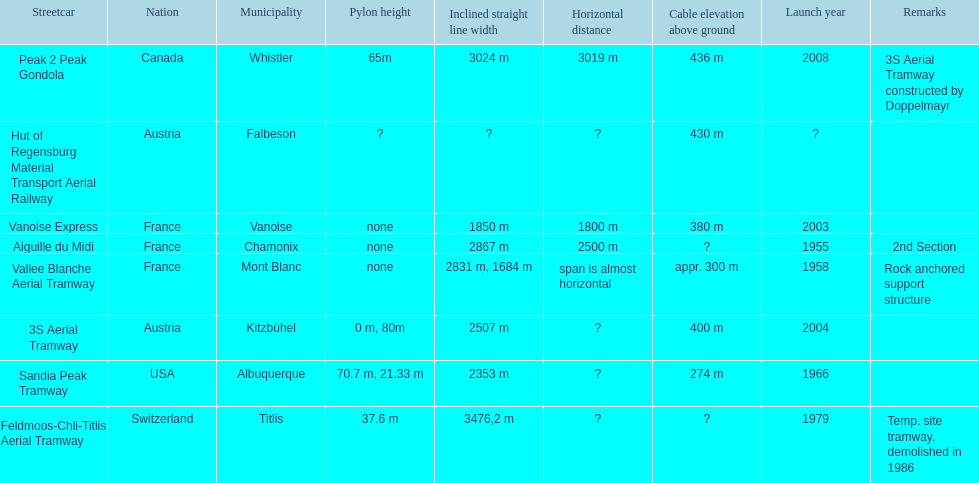What is the tramway that was developed directly before the 3s aerial tramway? Vanoise Express. 